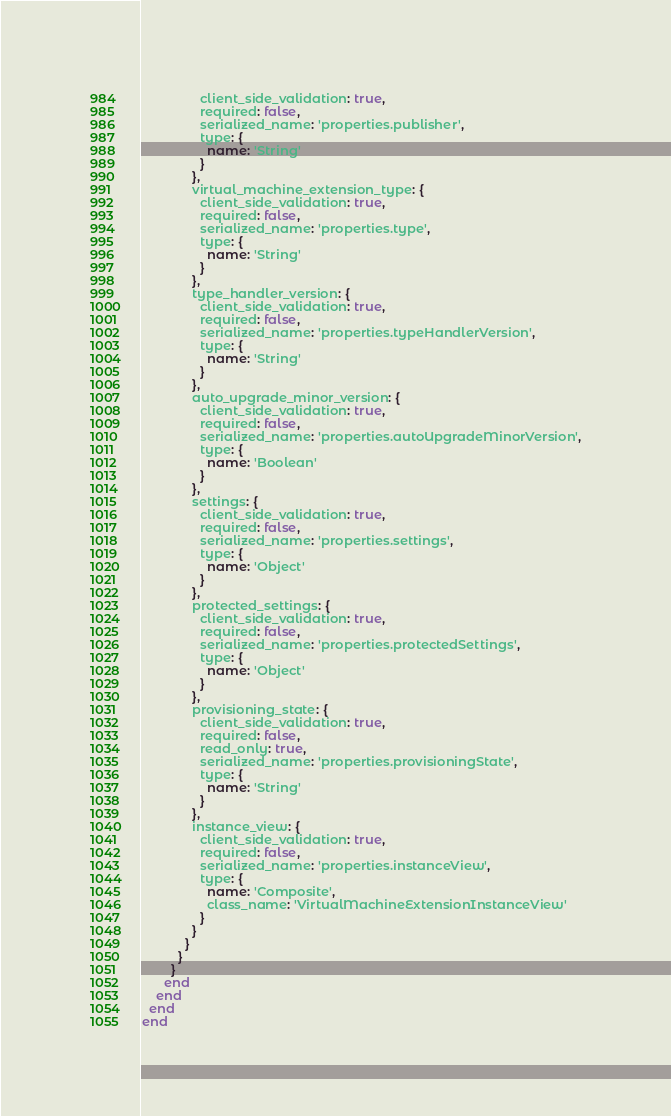<code> <loc_0><loc_0><loc_500><loc_500><_Ruby_>                client_side_validation: true,
                required: false,
                serialized_name: 'properties.publisher',
                type: {
                  name: 'String'
                }
              },
              virtual_machine_extension_type: {
                client_side_validation: true,
                required: false,
                serialized_name: 'properties.type',
                type: {
                  name: 'String'
                }
              },
              type_handler_version: {
                client_side_validation: true,
                required: false,
                serialized_name: 'properties.typeHandlerVersion',
                type: {
                  name: 'String'
                }
              },
              auto_upgrade_minor_version: {
                client_side_validation: true,
                required: false,
                serialized_name: 'properties.autoUpgradeMinorVersion',
                type: {
                  name: 'Boolean'
                }
              },
              settings: {
                client_side_validation: true,
                required: false,
                serialized_name: 'properties.settings',
                type: {
                  name: 'Object'
                }
              },
              protected_settings: {
                client_side_validation: true,
                required: false,
                serialized_name: 'properties.protectedSettings',
                type: {
                  name: 'Object'
                }
              },
              provisioning_state: {
                client_side_validation: true,
                required: false,
                read_only: true,
                serialized_name: 'properties.provisioningState',
                type: {
                  name: 'String'
                }
              },
              instance_view: {
                client_side_validation: true,
                required: false,
                serialized_name: 'properties.instanceView',
                type: {
                  name: 'Composite',
                  class_name: 'VirtualMachineExtensionInstanceView'
                }
              }
            }
          }
        }
      end
    end
  end
end
</code> 